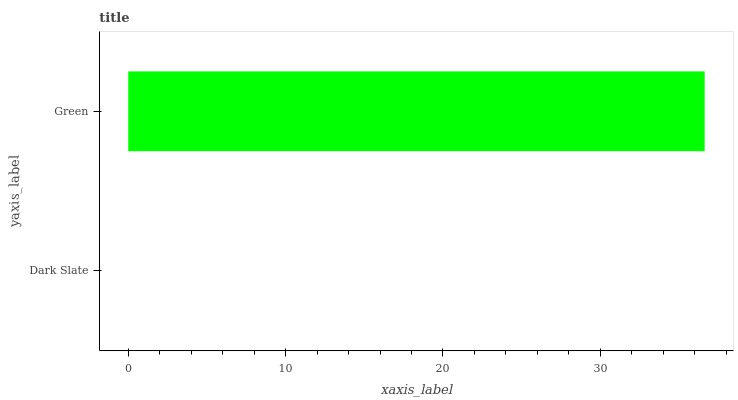Is Dark Slate the minimum?
Answer yes or no. Yes. Is Green the maximum?
Answer yes or no. Yes. Is Green the minimum?
Answer yes or no. No. Is Green greater than Dark Slate?
Answer yes or no. Yes. Is Dark Slate less than Green?
Answer yes or no. Yes. Is Dark Slate greater than Green?
Answer yes or no. No. Is Green less than Dark Slate?
Answer yes or no. No. Is Green the high median?
Answer yes or no. Yes. Is Dark Slate the low median?
Answer yes or no. Yes. Is Dark Slate the high median?
Answer yes or no. No. Is Green the low median?
Answer yes or no. No. 